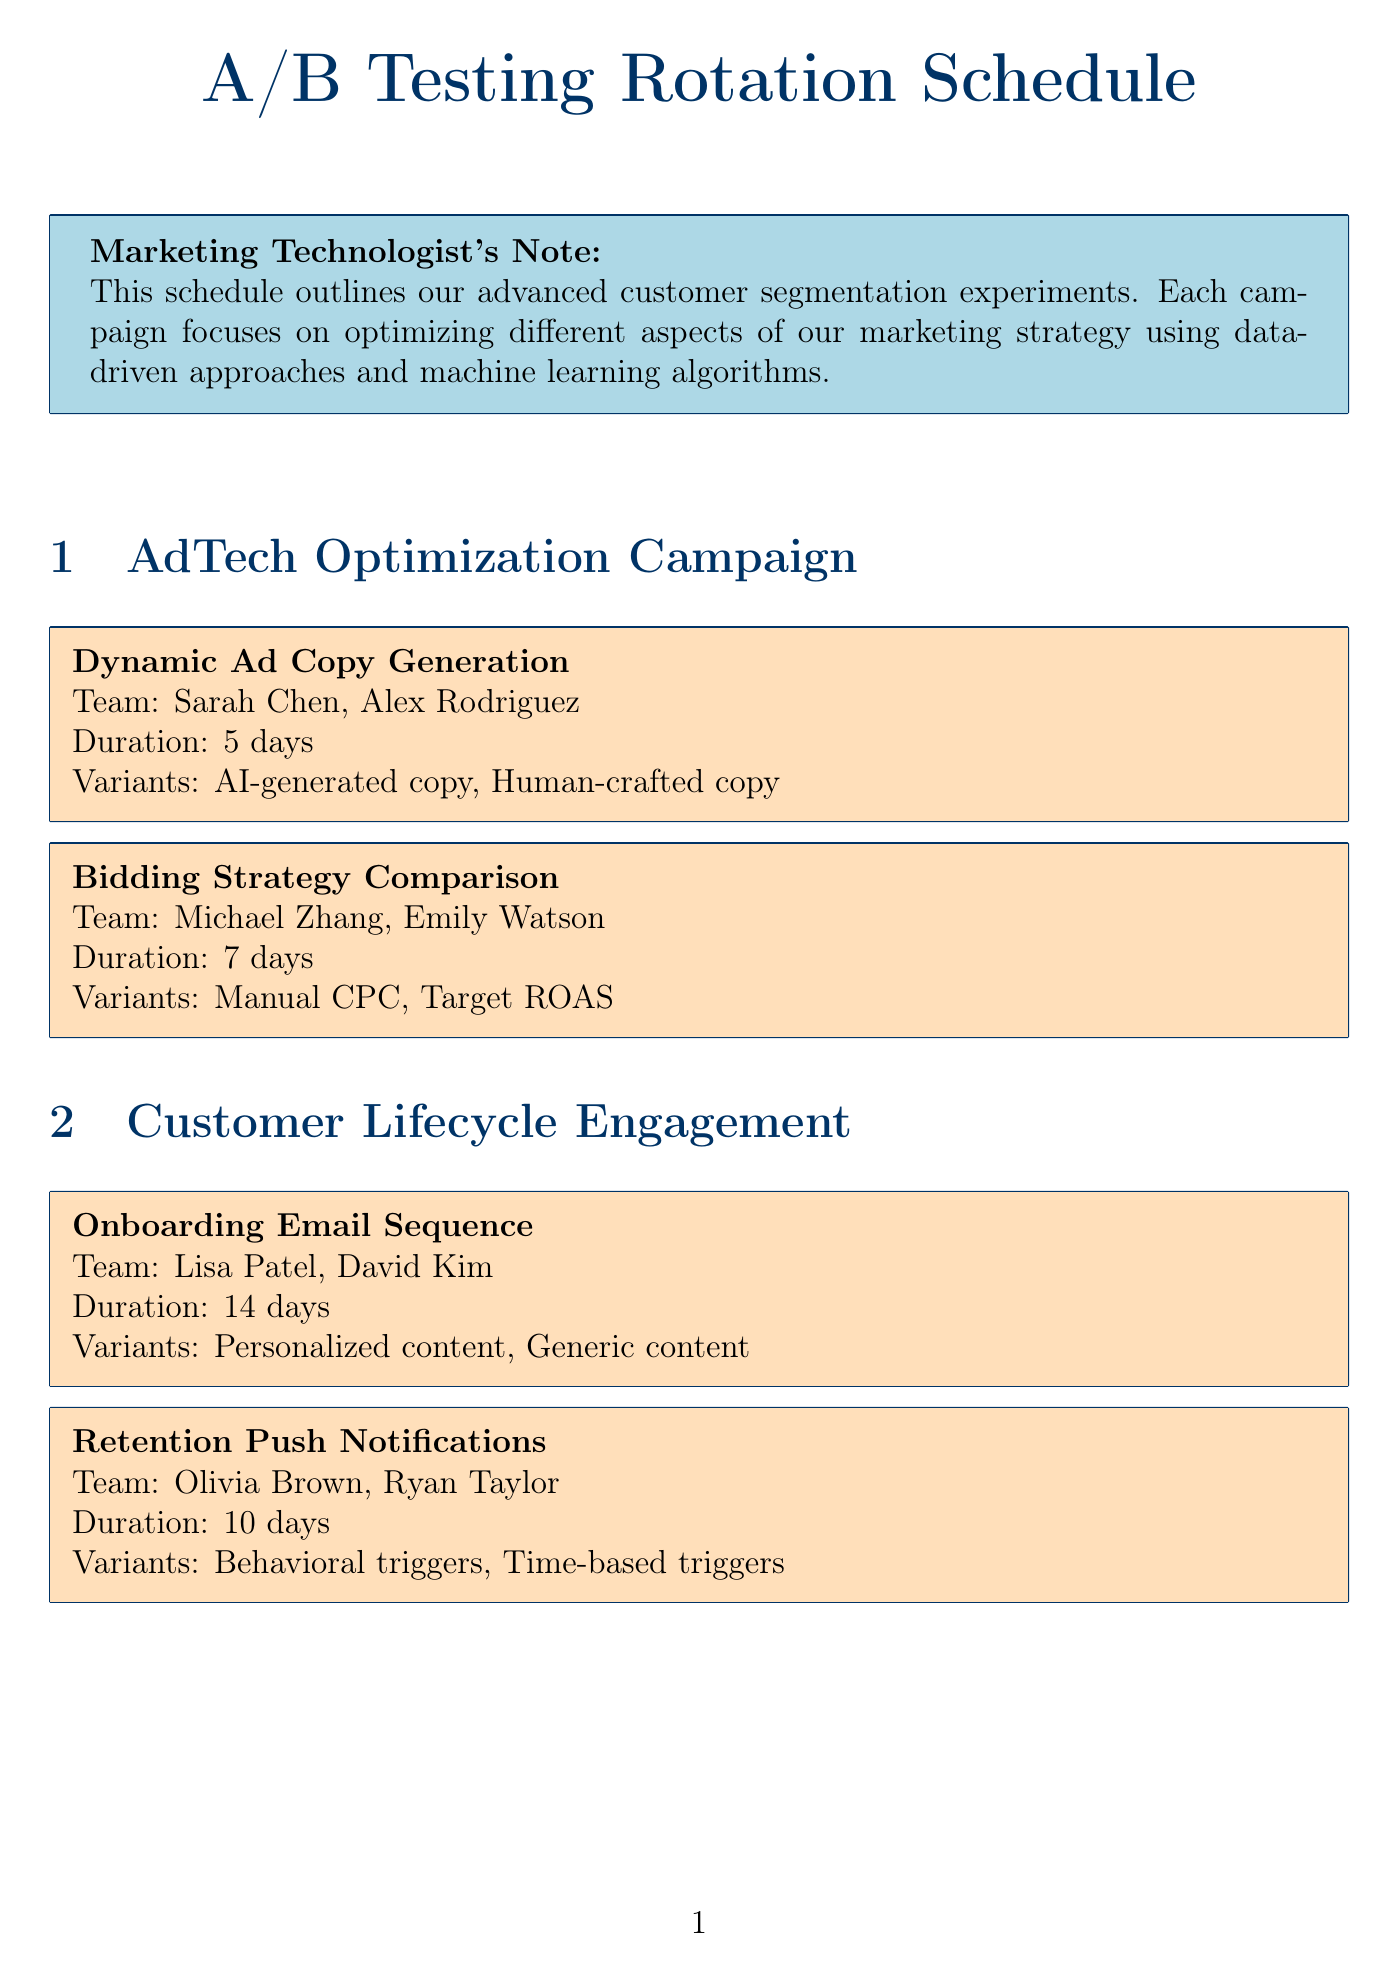What is the name of the first campaign? The first campaign listed in the document is "AdTech Optimization Campaign."
Answer: AdTech Optimization Campaign Who are the team members for the "Churn Prediction Model"? The team members assigned to the "Churn Prediction Model" are Sophia Lee and Marcus Johnson.
Answer: Sophia Lee, Marcus Johnson How long is the "Retention Push Notifications" experiment scheduled to run? The duration of the "Retention Push Notifications" experiment is indicated to be 10 days.
Answer: 10 days What variants are tested in the "Product Recommendation Algorithms"? The variants for the "Product Recommendation Algorithms" experiment are "Item-based collaborative filtering" and "Matrix factorization."
Answer: Item-based collaborative filtering, Matrix factorization How many days will the "TV to Digital Attribution" experiment last? The document states that the duration for the "TV to Digital Attribution" experiment is 45 days.
Answer: 45 days Which tool is specifically identified for A/B testing and personalization? The document specifies "Google Optimize" as a tool for A/B testing and personalization.
Answer: Google Optimize What is a recommended best practice according to the document? One of the best practices mentioned is to "Ensure statistical significance before concluding experiments."
Answer: Ensure statistical significance before concluding experiments Which experiment has the longest duration in the schedule? The experiment with the longest duration is "TV to Digital Attribution," which lasts 45 days.
Answer: TV to Digital Attribution Name a metric listed in the document. The document lists multiple metrics, such as "Conversion rate."
Answer: Conversion rate 